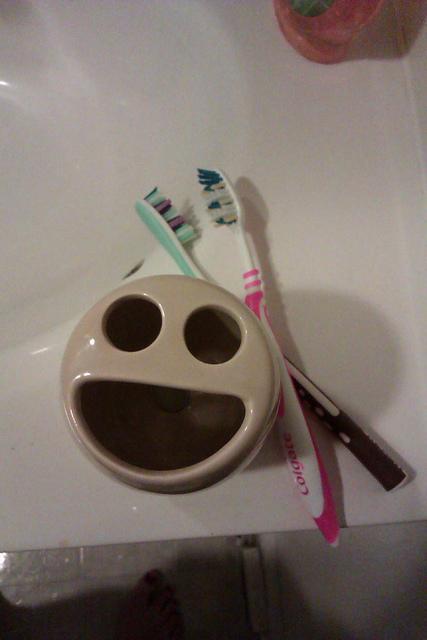What is the purpose of the cup? toothbrush holder 